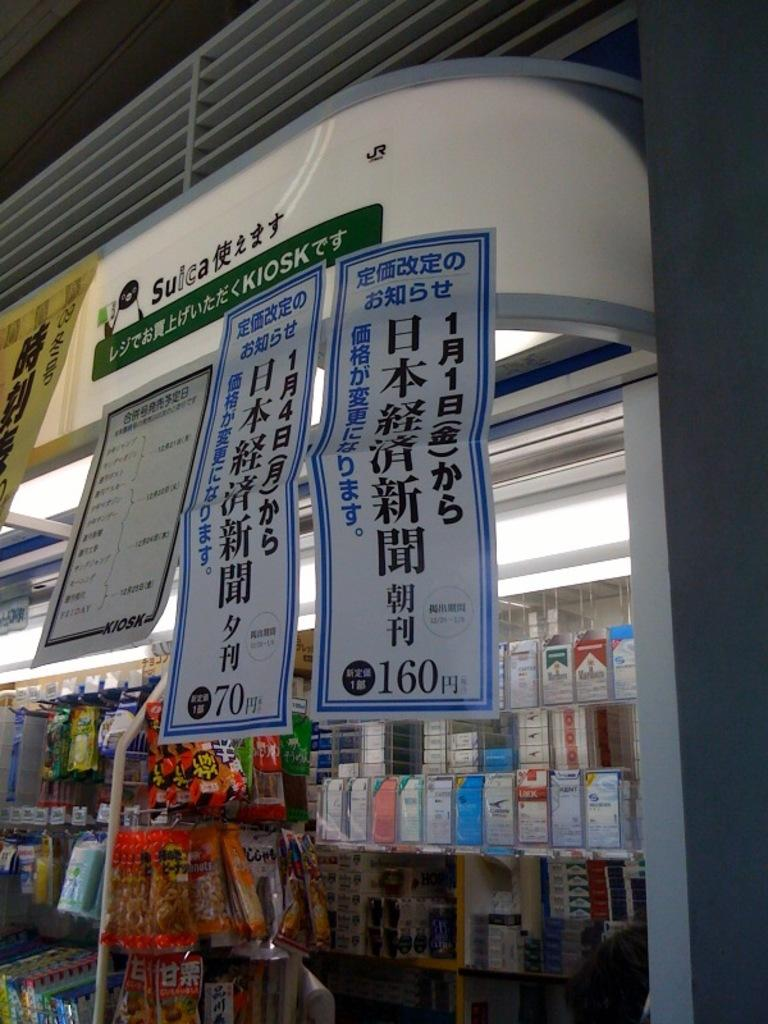<image>
Offer a succinct explanation of the picture presented. Inside a store window of chinese language and 160 in the right bottom corner 